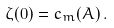<formula> <loc_0><loc_0><loc_500><loc_500>\zeta ( 0 ) = c _ { m } ( A ) \, .</formula> 